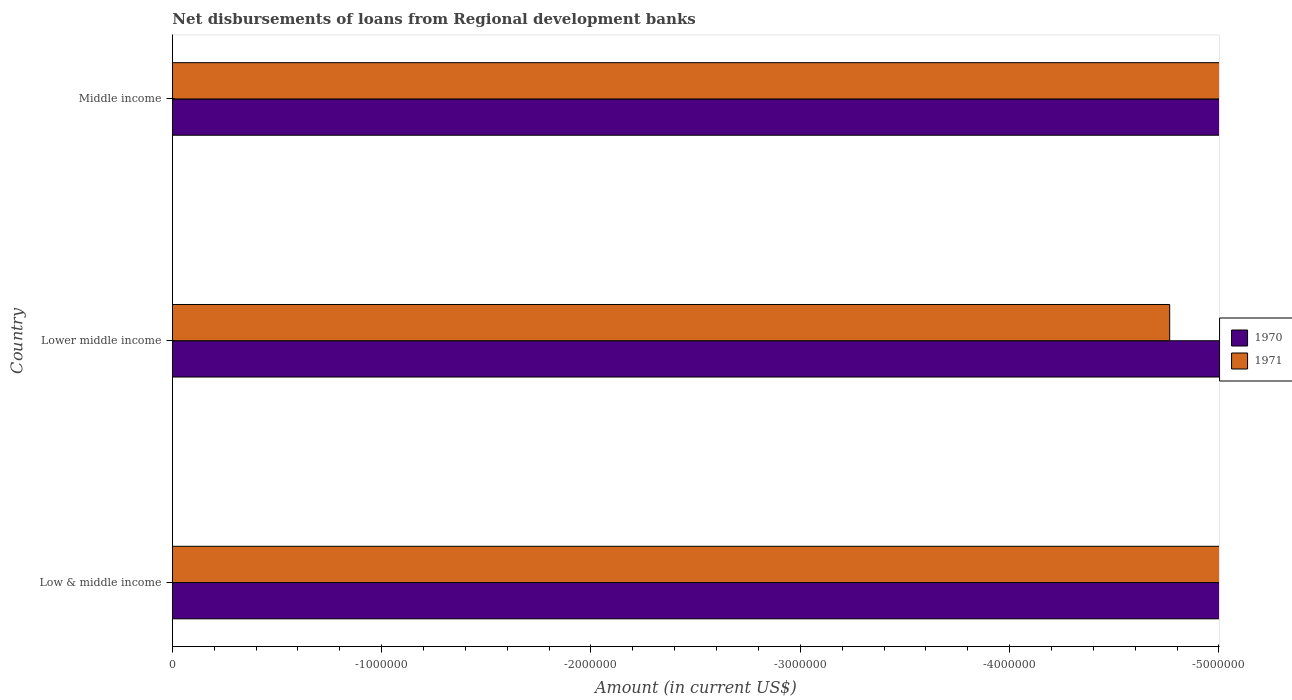How many different coloured bars are there?
Your answer should be compact. 0. How many bars are there on the 3rd tick from the top?
Make the answer very short. 0. What is the label of the 2nd group of bars from the top?
Keep it short and to the point. Lower middle income. Across all countries, what is the minimum amount of disbursements of loans from regional development banks in 1970?
Provide a succinct answer. 0. What is the total amount of disbursements of loans from regional development banks in 1971 in the graph?
Your answer should be compact. 0. What is the difference between the amount of disbursements of loans from regional development banks in 1970 in Lower middle income and the amount of disbursements of loans from regional development banks in 1971 in Low & middle income?
Your response must be concise. 0. In how many countries, is the amount of disbursements of loans from regional development banks in 1971 greater than the average amount of disbursements of loans from regional development banks in 1971 taken over all countries?
Provide a succinct answer. 0. How many bars are there?
Provide a succinct answer. 0. Are all the bars in the graph horizontal?
Offer a terse response. Yes. Are the values on the major ticks of X-axis written in scientific E-notation?
Provide a succinct answer. No. Does the graph contain grids?
Ensure brevity in your answer.  No. How many legend labels are there?
Offer a very short reply. 2. How are the legend labels stacked?
Keep it short and to the point. Vertical. What is the title of the graph?
Ensure brevity in your answer.  Net disbursements of loans from Regional development banks. Does "2005" appear as one of the legend labels in the graph?
Offer a very short reply. No. What is the label or title of the X-axis?
Provide a short and direct response. Amount (in current US$). What is the label or title of the Y-axis?
Make the answer very short. Country. What is the Amount (in current US$) of 1971 in Low & middle income?
Make the answer very short. 0. What is the Amount (in current US$) of 1970 in Middle income?
Offer a very short reply. 0. What is the total Amount (in current US$) in 1970 in the graph?
Make the answer very short. 0. What is the total Amount (in current US$) of 1971 in the graph?
Your response must be concise. 0. What is the average Amount (in current US$) in 1970 per country?
Your response must be concise. 0. 